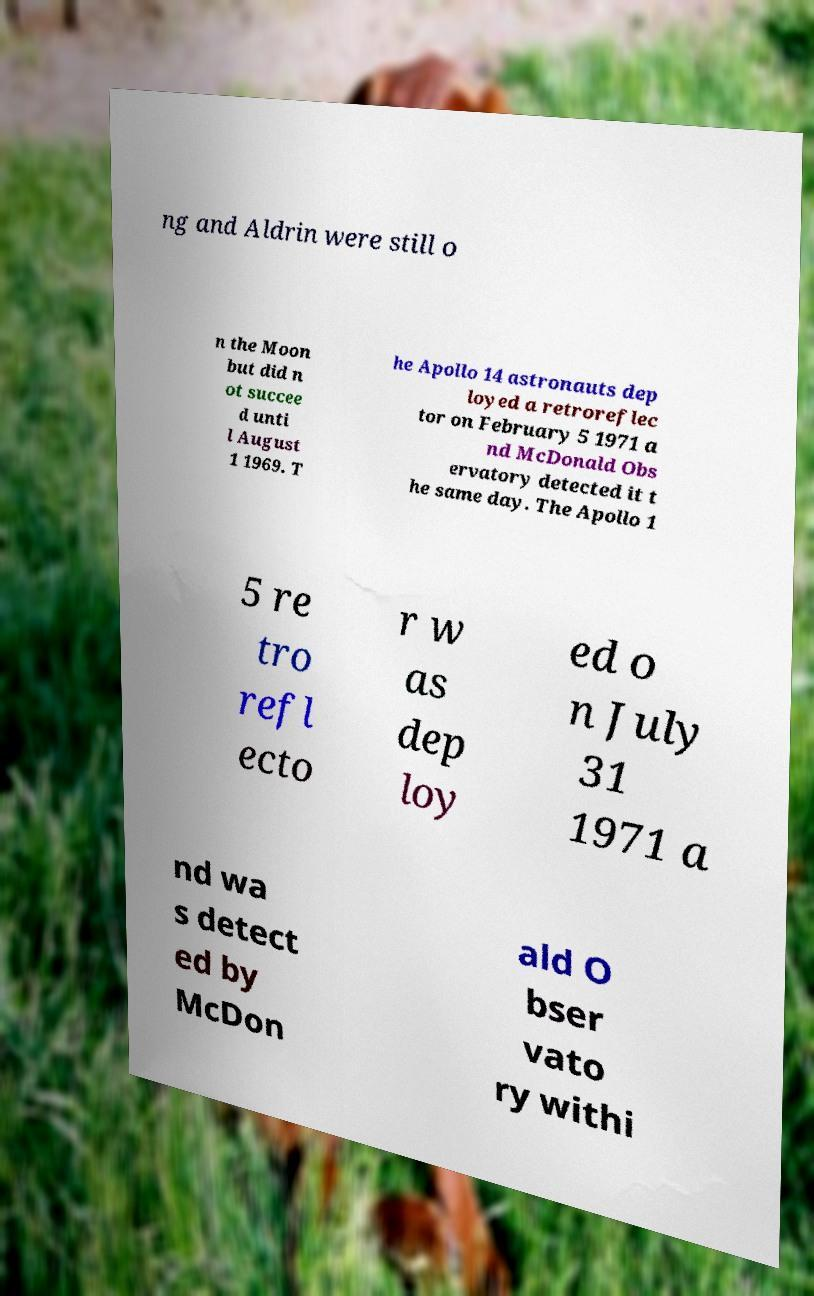I need the written content from this picture converted into text. Can you do that? ng and Aldrin were still o n the Moon but did n ot succee d unti l August 1 1969. T he Apollo 14 astronauts dep loyed a retroreflec tor on February 5 1971 a nd McDonald Obs ervatory detected it t he same day. The Apollo 1 5 re tro refl ecto r w as dep loy ed o n July 31 1971 a nd wa s detect ed by McDon ald O bser vato ry withi 